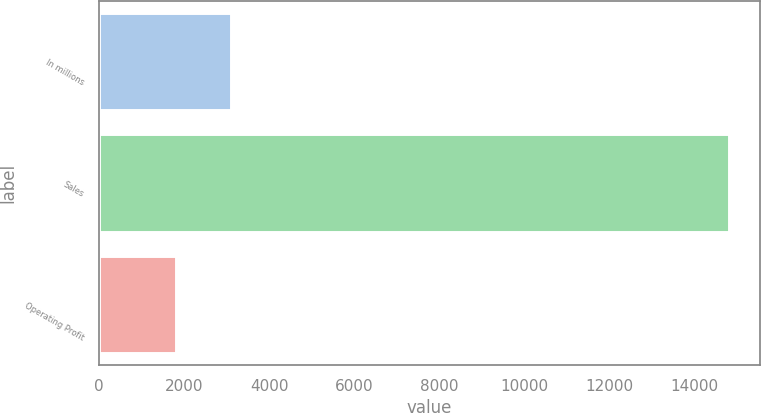Convert chart. <chart><loc_0><loc_0><loc_500><loc_500><bar_chart><fcel>In millions<fcel>Sales<fcel>Operating Profit<nl><fcel>3101.9<fcel>14810<fcel>1801<nl></chart> 